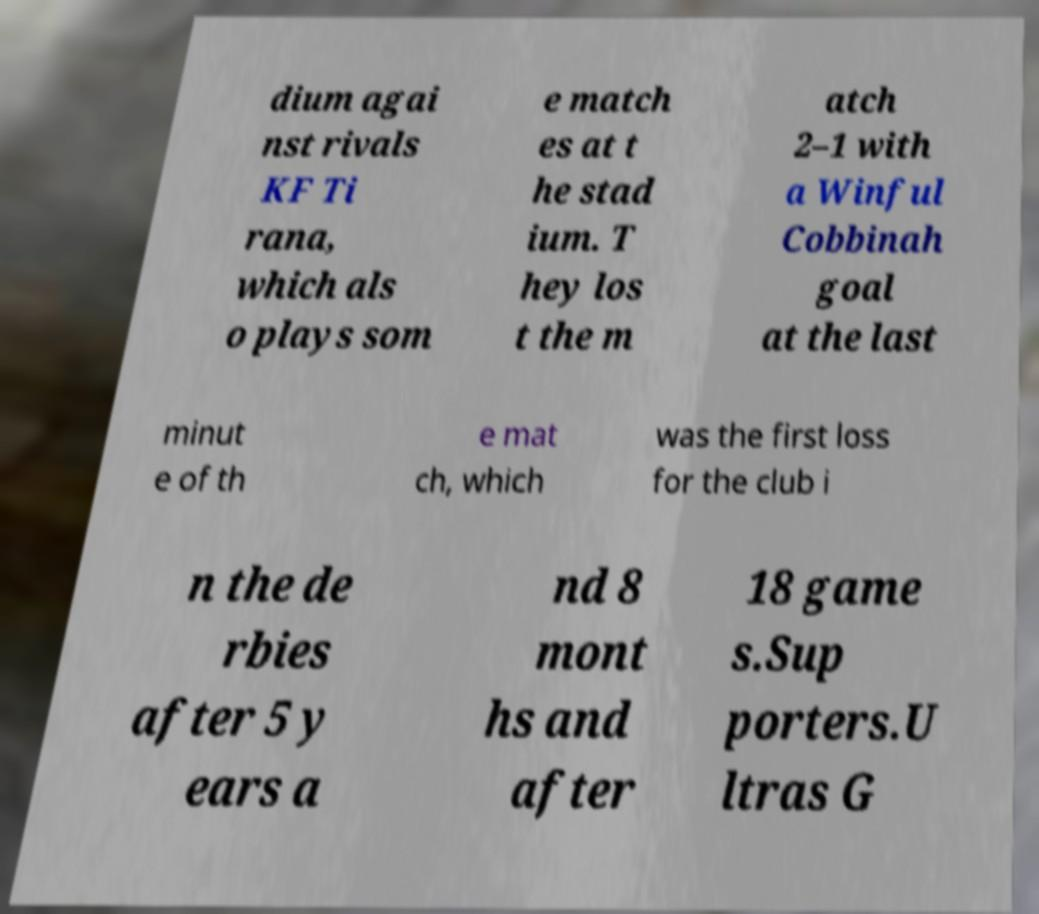Could you assist in decoding the text presented in this image and type it out clearly? dium agai nst rivals KF Ti rana, which als o plays som e match es at t he stad ium. T hey los t the m atch 2–1 with a Winful Cobbinah goal at the last minut e of th e mat ch, which was the first loss for the club i n the de rbies after 5 y ears a nd 8 mont hs and after 18 game s.Sup porters.U ltras G 